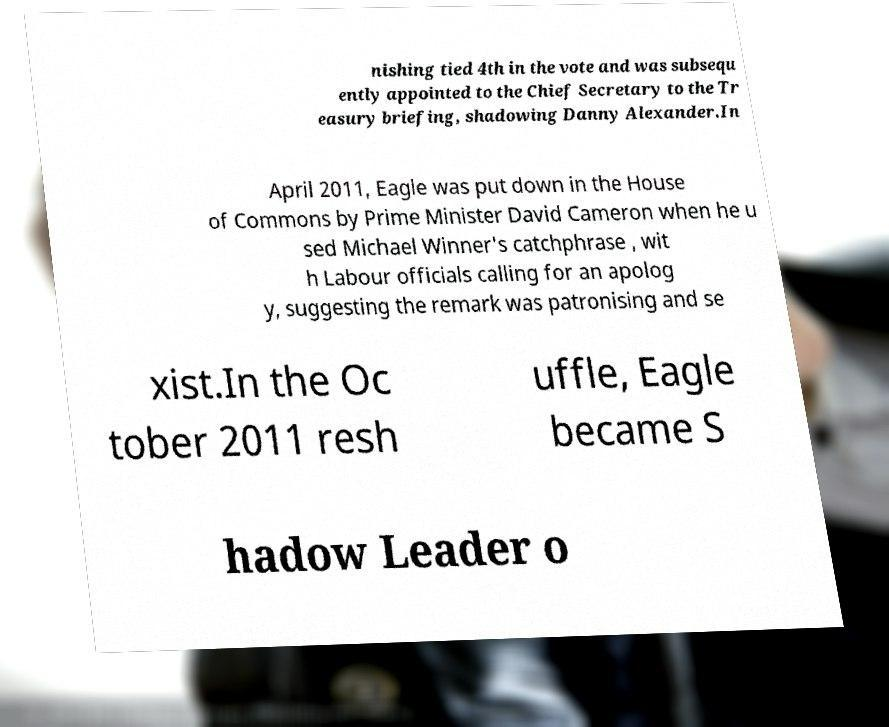Can you accurately transcribe the text from the provided image for me? nishing tied 4th in the vote and was subsequ ently appointed to the Chief Secretary to the Tr easury briefing, shadowing Danny Alexander.In April 2011, Eagle was put down in the House of Commons by Prime Minister David Cameron when he u sed Michael Winner's catchphrase , wit h Labour officials calling for an apolog y, suggesting the remark was patronising and se xist.In the Oc tober 2011 resh uffle, Eagle became S hadow Leader o 